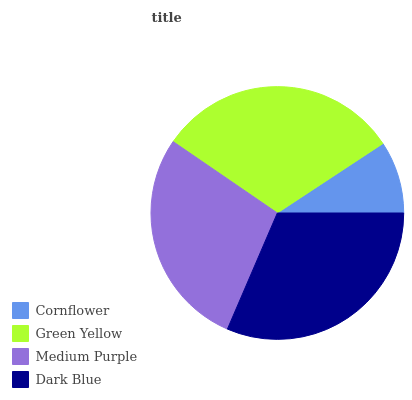Is Cornflower the minimum?
Answer yes or no. Yes. Is Dark Blue the maximum?
Answer yes or no. Yes. Is Green Yellow the minimum?
Answer yes or no. No. Is Green Yellow the maximum?
Answer yes or no. No. Is Green Yellow greater than Cornflower?
Answer yes or no. Yes. Is Cornflower less than Green Yellow?
Answer yes or no. Yes. Is Cornflower greater than Green Yellow?
Answer yes or no. No. Is Green Yellow less than Cornflower?
Answer yes or no. No. Is Green Yellow the high median?
Answer yes or no. Yes. Is Medium Purple the low median?
Answer yes or no. Yes. Is Dark Blue the high median?
Answer yes or no. No. Is Green Yellow the low median?
Answer yes or no. No. 